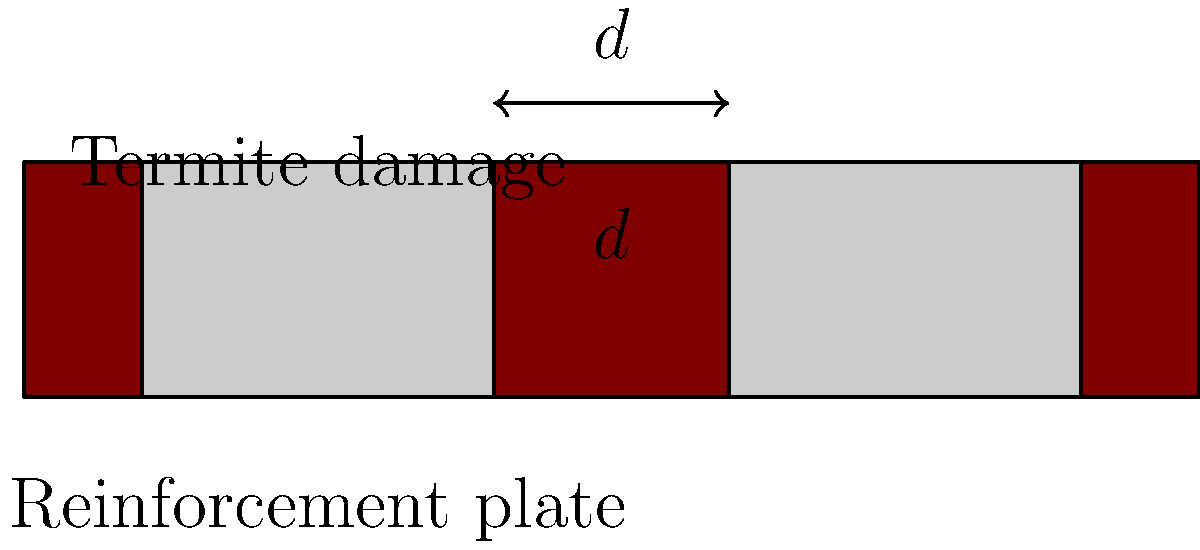A wooden beam has been weakened by termite damage in two locations. You plan to reinforce it with metal plates on either side of the damaged areas. If the beam is 10 feet long and the plates are each 3 feet wide, what is the optimal spacing $(d)$ between the plates to ensure maximum coverage and support? To determine the optimal spacing between the reinforcement plates, we'll follow these steps:

1. Understand the given information:
   - Beam length: 10 feet
   - Plate width: 3 feet each
   - Two plates are used

2. Calculate the total length covered by the plates:
   $2 \times 3 \text{ feet} = 6 \text{ feet}$

3. Calculate the remaining length to be distributed:
   $10 \text{ feet} - 6 \text{ feet} = 4 \text{ feet}$

4. Distribute the remaining length:
   - 1 foot at each end of the beam
   - The rest between the plates

5. Calculate the optimal spacing $(d)$:
   $d = 4 \text{ feet} - (1 \text{ foot} + 1 \text{ foot}) = 2 \text{ feet}$

This spacing ensures that:
- The plates cover the maximum area possible
- There's equal protection at both ends of the beam
- The gap between plates is minimized, providing better overall support
Answer: 2 feet 